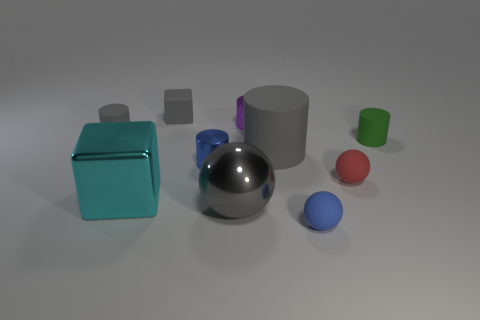Subtract all green cylinders. How many cylinders are left? 4 Subtract all large cylinders. How many cylinders are left? 4 Subtract 2 cylinders. How many cylinders are left? 3 Subtract all cyan cylinders. Subtract all purple spheres. How many cylinders are left? 5 Subtract all blocks. How many objects are left? 8 Subtract 0 brown blocks. How many objects are left? 10 Subtract all large gray metal cylinders. Subtract all large shiny balls. How many objects are left? 9 Add 2 big rubber cylinders. How many big rubber cylinders are left? 3 Add 4 tiny rubber spheres. How many tiny rubber spheres exist? 6 